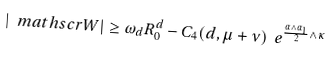Convert formula to latex. <formula><loc_0><loc_0><loc_500><loc_500>| \ m a t h s c r { W } | \geq \omega _ { d } R _ { 0 } ^ { d } - C _ { 4 } ( d , \mu + \nu ) \ e ^ { \frac { \alpha \wedge \alpha _ { 1 } } { 2 } \wedge \kappa }</formula> 